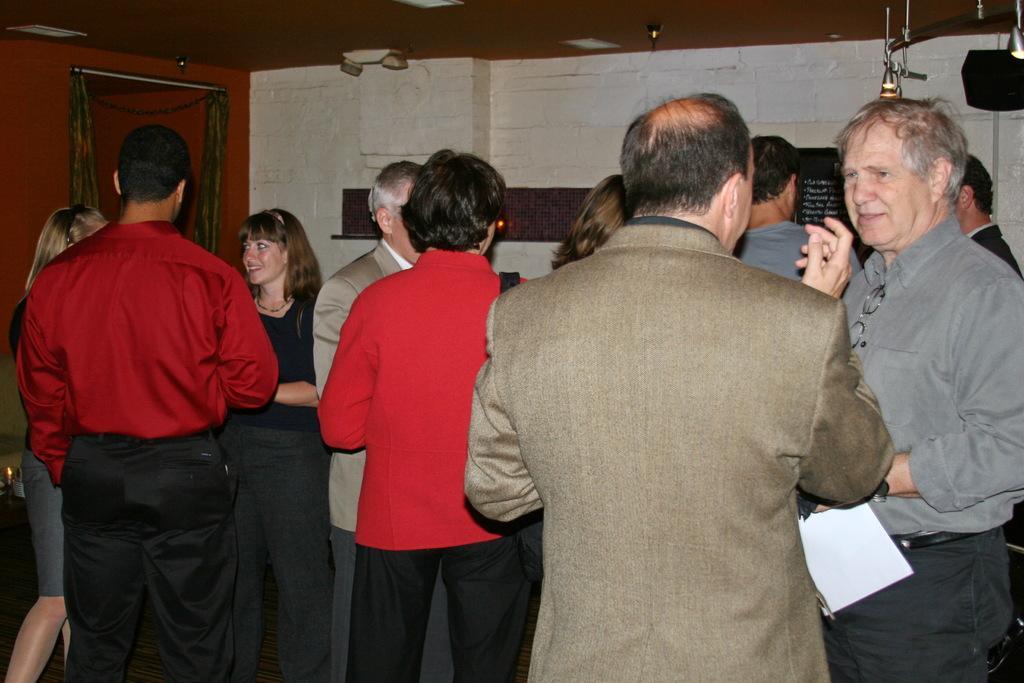How would you summarize this image in a sentence or two? In this image I can see number of people are standing and on the right side I can see one of them is holding a white colour paper. In the background I can see a black colour thing and on it I can see something is written. On the top right corner of this image I can see an iron rod, a black colour thing and on the left side I can see few lights on the ceiling. 